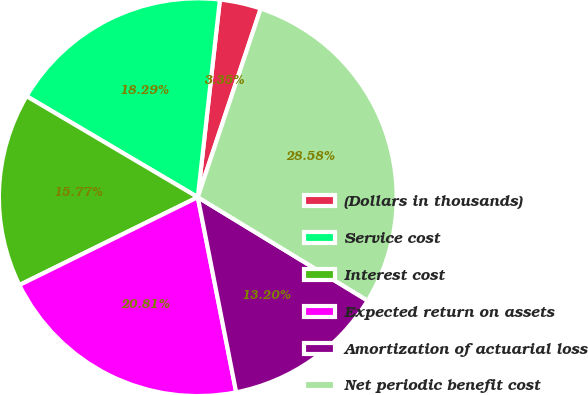Convert chart. <chart><loc_0><loc_0><loc_500><loc_500><pie_chart><fcel>(Dollars in thousands)<fcel>Service cost<fcel>Interest cost<fcel>Expected return on assets<fcel>Amortization of actuarial loss<fcel>Net periodic benefit cost<nl><fcel>3.35%<fcel>18.29%<fcel>15.77%<fcel>20.81%<fcel>13.2%<fcel>28.58%<nl></chart> 